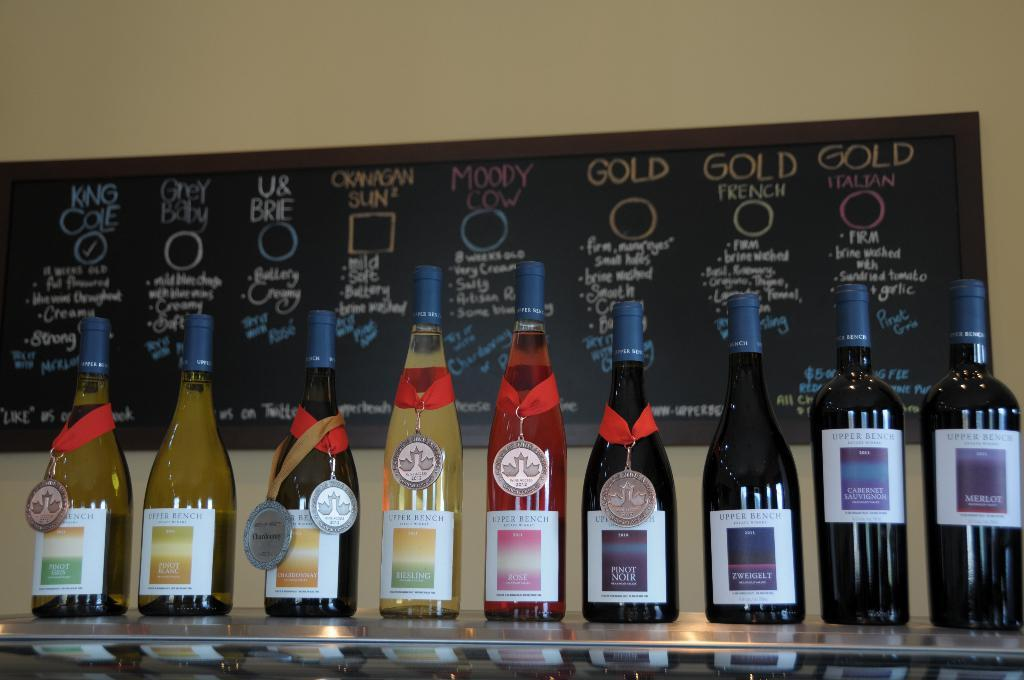Provide a one-sentence caption for the provided image. a shelf of alcohol bottles in front of a board that says 'moody cow' and 'gold' and much more. 